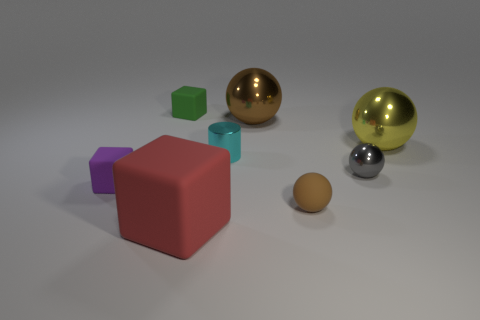Add 2 small cyan cylinders. How many objects exist? 10 Subtract all cylinders. How many objects are left? 7 Subtract all green blocks. Subtract all small brown things. How many objects are left? 6 Add 7 large brown shiny things. How many large brown shiny things are left? 8 Add 4 large blue shiny blocks. How many large blue shiny blocks exist? 4 Subtract 2 brown spheres. How many objects are left? 6 